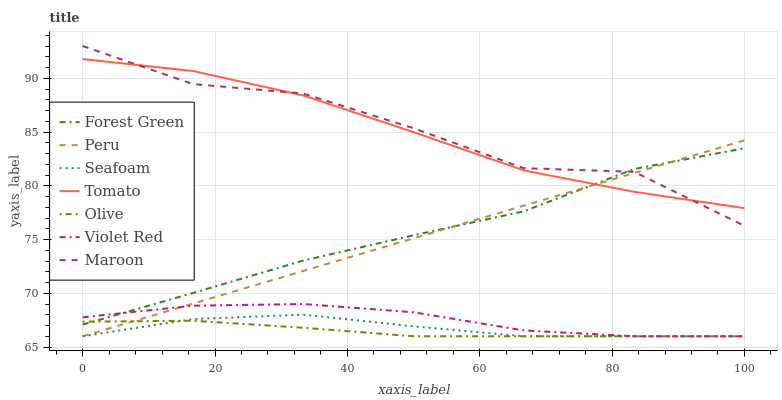Does Olive have the minimum area under the curve?
Answer yes or no. Yes. Does Maroon have the maximum area under the curve?
Answer yes or no. Yes. Does Violet Red have the minimum area under the curve?
Answer yes or no. No. Does Violet Red have the maximum area under the curve?
Answer yes or no. No. Is Peru the smoothest?
Answer yes or no. Yes. Is Maroon the roughest?
Answer yes or no. Yes. Is Violet Red the smoothest?
Answer yes or no. No. Is Violet Red the roughest?
Answer yes or no. No. Does Violet Red have the lowest value?
Answer yes or no. Yes. Does Maroon have the lowest value?
Answer yes or no. No. Does Maroon have the highest value?
Answer yes or no. Yes. Does Violet Red have the highest value?
Answer yes or no. No. Is Violet Red less than Tomato?
Answer yes or no. Yes. Is Forest Green greater than Seafoam?
Answer yes or no. Yes. Does Maroon intersect Peru?
Answer yes or no. Yes. Is Maroon less than Peru?
Answer yes or no. No. Is Maroon greater than Peru?
Answer yes or no. No. Does Violet Red intersect Tomato?
Answer yes or no. No. 